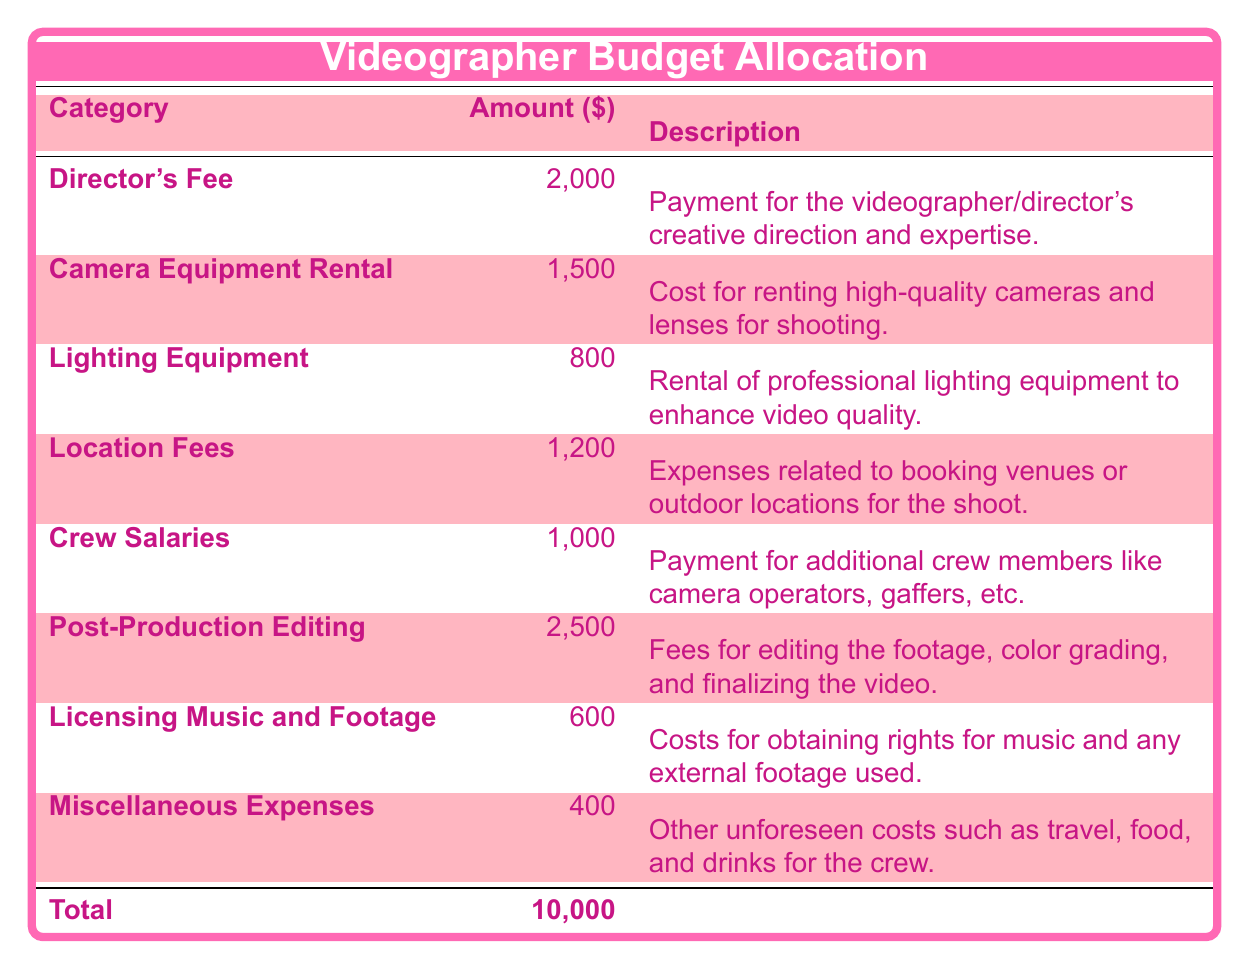What is the total budget allocation for the music video? The total budget allocation is stated in the table as the last entry under the "Amount" column. There, it shows as $10,000.
Answer: 10,000 What is the amount allocated for post-production editing? The table lists the "Post-Production Editing" category, where the amount specified is $2,500.
Answer: 2,500 Is the amount for camera equipment rental higher than the amount for crew salaries? To determine this, we compare the two amounts from the table: the "Camera Equipment Rental" is $1,500 and "Crew Salaries" is $1,000. Since $1,500 is greater than $1,000, the statement is true.
Answer: Yes What is the total amount allocated for lighting equipment and location fees combined? First, we find the amounts for "Lighting Equipment" which is $800 and "Location Fees" which is $1,200. Adding these two together gives $800 + $1,200 = $2,000.
Answer: 2,000 Are the total miscellaneous expenses less than $500? The table shows the "Miscellaneous Expenses" as $400. Since $400 is less than $500, the statement is true.
Answer: Yes How much more is dedicated to the director's fee compared to licensing music and footage? We compare the amounts: the "Director's Fee" is $2,000 and "Licensing Music and Footage" is $600. The difference is calculated as $2,000 - $600 = $1,400.
Answer: 1,400 What is the average amount allocated to the categories excluding miscellaneous expenses? To find the average, we first sum the amounts of the other categories (excluding miscellaneous): Director's Fee ($2,000) + Camera Equipment Rental ($1,500) + Lighting Equipment ($800) + Location Fees ($1,200) + Crew Salaries ($1,000) + Post-Production Editing ($2,500) + Licensing Music and Footage ($600). This totals to $9,600. There are 7 categories, so we calculate the average as $9,600 / 7 = approximately $1,371.43.
Answer: Approximately 1,371.43 